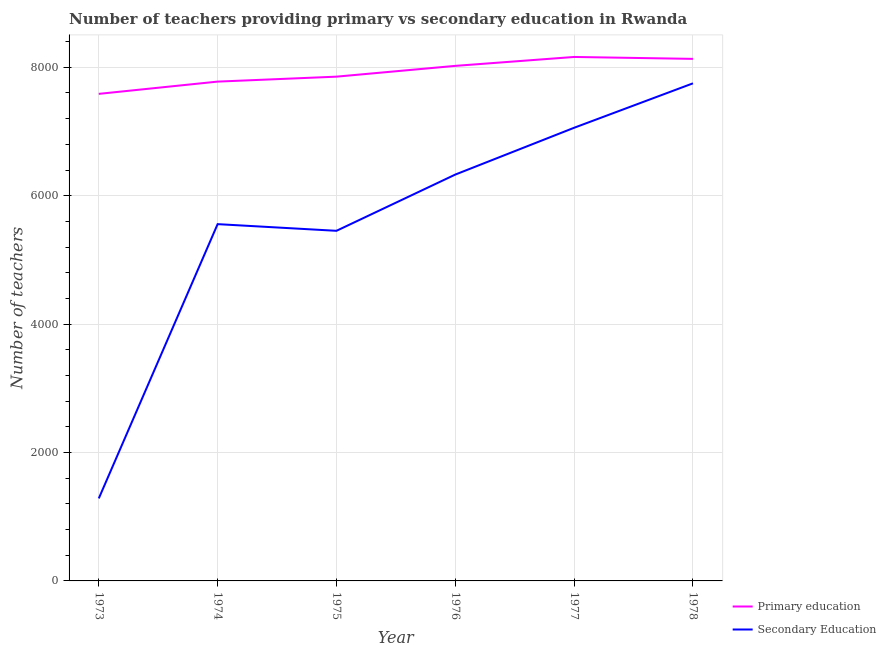Is the number of lines equal to the number of legend labels?
Give a very brief answer. Yes. What is the number of secondary teachers in 1978?
Give a very brief answer. 7750. Across all years, what is the maximum number of secondary teachers?
Your answer should be very brief. 7750. Across all years, what is the minimum number of secondary teachers?
Your answer should be very brief. 1285. In which year was the number of secondary teachers maximum?
Offer a very short reply. 1978. What is the total number of secondary teachers in the graph?
Your response must be concise. 3.34e+04. What is the difference between the number of primary teachers in 1974 and that in 1978?
Your answer should be compact. -354. What is the difference between the number of secondary teachers in 1974 and the number of primary teachers in 1973?
Provide a succinct answer. -2029. What is the average number of secondary teachers per year?
Ensure brevity in your answer.  5572. In the year 1974, what is the difference between the number of primary teachers and number of secondary teachers?
Your response must be concise. 2220. What is the ratio of the number of primary teachers in 1974 to that in 1977?
Offer a terse response. 0.95. Is the number of secondary teachers in 1973 less than that in 1975?
Your answer should be very brief. Yes. Is the difference between the number of primary teachers in 1974 and 1978 greater than the difference between the number of secondary teachers in 1974 and 1978?
Your response must be concise. Yes. What is the difference between the highest and the second highest number of secondary teachers?
Give a very brief answer. 692. What is the difference between the highest and the lowest number of secondary teachers?
Your answer should be very brief. 6465. Is the number of primary teachers strictly greater than the number of secondary teachers over the years?
Offer a very short reply. Yes. How many lines are there?
Offer a very short reply. 2. How many years are there in the graph?
Provide a short and direct response. 6. What is the difference between two consecutive major ticks on the Y-axis?
Keep it short and to the point. 2000. Does the graph contain any zero values?
Provide a short and direct response. No. Where does the legend appear in the graph?
Your response must be concise. Bottom right. How are the legend labels stacked?
Your answer should be very brief. Vertical. What is the title of the graph?
Your response must be concise. Number of teachers providing primary vs secondary education in Rwanda. Does "Commercial service exports" appear as one of the legend labels in the graph?
Ensure brevity in your answer.  No. What is the label or title of the Y-axis?
Ensure brevity in your answer.  Number of teachers. What is the Number of teachers in Primary education in 1973?
Provide a short and direct response. 7586. What is the Number of teachers in Secondary Education in 1973?
Your answer should be compact. 1285. What is the Number of teachers of Primary education in 1974?
Provide a succinct answer. 7777. What is the Number of teachers of Secondary Education in 1974?
Offer a terse response. 5557. What is the Number of teachers in Primary education in 1975?
Offer a terse response. 7854. What is the Number of teachers in Secondary Education in 1975?
Make the answer very short. 5453. What is the Number of teachers of Primary education in 1976?
Give a very brief answer. 8022. What is the Number of teachers of Secondary Education in 1976?
Give a very brief answer. 6329. What is the Number of teachers in Primary education in 1977?
Offer a terse response. 8161. What is the Number of teachers of Secondary Education in 1977?
Make the answer very short. 7058. What is the Number of teachers in Primary education in 1978?
Your answer should be very brief. 8131. What is the Number of teachers of Secondary Education in 1978?
Provide a succinct answer. 7750. Across all years, what is the maximum Number of teachers in Primary education?
Your answer should be compact. 8161. Across all years, what is the maximum Number of teachers of Secondary Education?
Provide a succinct answer. 7750. Across all years, what is the minimum Number of teachers of Primary education?
Keep it short and to the point. 7586. Across all years, what is the minimum Number of teachers in Secondary Education?
Provide a short and direct response. 1285. What is the total Number of teachers of Primary education in the graph?
Offer a terse response. 4.75e+04. What is the total Number of teachers of Secondary Education in the graph?
Give a very brief answer. 3.34e+04. What is the difference between the Number of teachers of Primary education in 1973 and that in 1974?
Ensure brevity in your answer.  -191. What is the difference between the Number of teachers of Secondary Education in 1973 and that in 1974?
Your answer should be very brief. -4272. What is the difference between the Number of teachers in Primary education in 1973 and that in 1975?
Your response must be concise. -268. What is the difference between the Number of teachers in Secondary Education in 1973 and that in 1975?
Offer a terse response. -4168. What is the difference between the Number of teachers in Primary education in 1973 and that in 1976?
Your answer should be very brief. -436. What is the difference between the Number of teachers in Secondary Education in 1973 and that in 1976?
Make the answer very short. -5044. What is the difference between the Number of teachers in Primary education in 1973 and that in 1977?
Your answer should be very brief. -575. What is the difference between the Number of teachers in Secondary Education in 1973 and that in 1977?
Ensure brevity in your answer.  -5773. What is the difference between the Number of teachers in Primary education in 1973 and that in 1978?
Make the answer very short. -545. What is the difference between the Number of teachers of Secondary Education in 1973 and that in 1978?
Ensure brevity in your answer.  -6465. What is the difference between the Number of teachers of Primary education in 1974 and that in 1975?
Offer a very short reply. -77. What is the difference between the Number of teachers of Secondary Education in 1974 and that in 1975?
Your response must be concise. 104. What is the difference between the Number of teachers of Primary education in 1974 and that in 1976?
Ensure brevity in your answer.  -245. What is the difference between the Number of teachers in Secondary Education in 1974 and that in 1976?
Provide a succinct answer. -772. What is the difference between the Number of teachers in Primary education in 1974 and that in 1977?
Offer a terse response. -384. What is the difference between the Number of teachers of Secondary Education in 1974 and that in 1977?
Provide a succinct answer. -1501. What is the difference between the Number of teachers of Primary education in 1974 and that in 1978?
Give a very brief answer. -354. What is the difference between the Number of teachers of Secondary Education in 1974 and that in 1978?
Your answer should be very brief. -2193. What is the difference between the Number of teachers in Primary education in 1975 and that in 1976?
Make the answer very short. -168. What is the difference between the Number of teachers of Secondary Education in 1975 and that in 1976?
Provide a short and direct response. -876. What is the difference between the Number of teachers in Primary education in 1975 and that in 1977?
Ensure brevity in your answer.  -307. What is the difference between the Number of teachers of Secondary Education in 1975 and that in 1977?
Provide a succinct answer. -1605. What is the difference between the Number of teachers in Primary education in 1975 and that in 1978?
Provide a short and direct response. -277. What is the difference between the Number of teachers in Secondary Education in 1975 and that in 1978?
Offer a very short reply. -2297. What is the difference between the Number of teachers in Primary education in 1976 and that in 1977?
Keep it short and to the point. -139. What is the difference between the Number of teachers in Secondary Education in 1976 and that in 1977?
Keep it short and to the point. -729. What is the difference between the Number of teachers of Primary education in 1976 and that in 1978?
Keep it short and to the point. -109. What is the difference between the Number of teachers of Secondary Education in 1976 and that in 1978?
Ensure brevity in your answer.  -1421. What is the difference between the Number of teachers in Primary education in 1977 and that in 1978?
Ensure brevity in your answer.  30. What is the difference between the Number of teachers in Secondary Education in 1977 and that in 1978?
Provide a short and direct response. -692. What is the difference between the Number of teachers of Primary education in 1973 and the Number of teachers of Secondary Education in 1974?
Your response must be concise. 2029. What is the difference between the Number of teachers in Primary education in 1973 and the Number of teachers in Secondary Education in 1975?
Offer a very short reply. 2133. What is the difference between the Number of teachers in Primary education in 1973 and the Number of teachers in Secondary Education in 1976?
Give a very brief answer. 1257. What is the difference between the Number of teachers of Primary education in 1973 and the Number of teachers of Secondary Education in 1977?
Give a very brief answer. 528. What is the difference between the Number of teachers in Primary education in 1973 and the Number of teachers in Secondary Education in 1978?
Provide a short and direct response. -164. What is the difference between the Number of teachers in Primary education in 1974 and the Number of teachers in Secondary Education in 1975?
Give a very brief answer. 2324. What is the difference between the Number of teachers of Primary education in 1974 and the Number of teachers of Secondary Education in 1976?
Offer a very short reply. 1448. What is the difference between the Number of teachers of Primary education in 1974 and the Number of teachers of Secondary Education in 1977?
Offer a very short reply. 719. What is the difference between the Number of teachers of Primary education in 1974 and the Number of teachers of Secondary Education in 1978?
Your answer should be compact. 27. What is the difference between the Number of teachers of Primary education in 1975 and the Number of teachers of Secondary Education in 1976?
Offer a terse response. 1525. What is the difference between the Number of teachers in Primary education in 1975 and the Number of teachers in Secondary Education in 1977?
Your answer should be very brief. 796. What is the difference between the Number of teachers in Primary education in 1975 and the Number of teachers in Secondary Education in 1978?
Offer a very short reply. 104. What is the difference between the Number of teachers in Primary education in 1976 and the Number of teachers in Secondary Education in 1977?
Ensure brevity in your answer.  964. What is the difference between the Number of teachers of Primary education in 1976 and the Number of teachers of Secondary Education in 1978?
Provide a short and direct response. 272. What is the difference between the Number of teachers of Primary education in 1977 and the Number of teachers of Secondary Education in 1978?
Ensure brevity in your answer.  411. What is the average Number of teachers of Primary education per year?
Provide a short and direct response. 7921.83. What is the average Number of teachers in Secondary Education per year?
Provide a succinct answer. 5572. In the year 1973, what is the difference between the Number of teachers of Primary education and Number of teachers of Secondary Education?
Keep it short and to the point. 6301. In the year 1974, what is the difference between the Number of teachers of Primary education and Number of teachers of Secondary Education?
Provide a short and direct response. 2220. In the year 1975, what is the difference between the Number of teachers in Primary education and Number of teachers in Secondary Education?
Offer a very short reply. 2401. In the year 1976, what is the difference between the Number of teachers of Primary education and Number of teachers of Secondary Education?
Offer a terse response. 1693. In the year 1977, what is the difference between the Number of teachers in Primary education and Number of teachers in Secondary Education?
Your answer should be compact. 1103. In the year 1978, what is the difference between the Number of teachers of Primary education and Number of teachers of Secondary Education?
Offer a terse response. 381. What is the ratio of the Number of teachers in Primary education in 1973 to that in 1974?
Your answer should be compact. 0.98. What is the ratio of the Number of teachers in Secondary Education in 1973 to that in 1974?
Provide a short and direct response. 0.23. What is the ratio of the Number of teachers in Primary education in 1973 to that in 1975?
Offer a terse response. 0.97. What is the ratio of the Number of teachers in Secondary Education in 1973 to that in 1975?
Offer a very short reply. 0.24. What is the ratio of the Number of teachers of Primary education in 1973 to that in 1976?
Offer a terse response. 0.95. What is the ratio of the Number of teachers in Secondary Education in 1973 to that in 1976?
Your answer should be very brief. 0.2. What is the ratio of the Number of teachers in Primary education in 1973 to that in 1977?
Your response must be concise. 0.93. What is the ratio of the Number of teachers of Secondary Education in 1973 to that in 1977?
Your response must be concise. 0.18. What is the ratio of the Number of teachers of Primary education in 1973 to that in 1978?
Your response must be concise. 0.93. What is the ratio of the Number of teachers of Secondary Education in 1973 to that in 1978?
Your answer should be compact. 0.17. What is the ratio of the Number of teachers of Primary education in 1974 to that in 1975?
Keep it short and to the point. 0.99. What is the ratio of the Number of teachers of Secondary Education in 1974 to that in 1975?
Provide a succinct answer. 1.02. What is the ratio of the Number of teachers of Primary education in 1974 to that in 1976?
Keep it short and to the point. 0.97. What is the ratio of the Number of teachers of Secondary Education in 1974 to that in 1976?
Provide a short and direct response. 0.88. What is the ratio of the Number of teachers in Primary education in 1974 to that in 1977?
Your answer should be compact. 0.95. What is the ratio of the Number of teachers of Secondary Education in 1974 to that in 1977?
Offer a very short reply. 0.79. What is the ratio of the Number of teachers in Primary education in 1974 to that in 1978?
Your response must be concise. 0.96. What is the ratio of the Number of teachers of Secondary Education in 1974 to that in 1978?
Provide a short and direct response. 0.72. What is the ratio of the Number of teachers of Primary education in 1975 to that in 1976?
Your answer should be compact. 0.98. What is the ratio of the Number of teachers in Secondary Education in 1975 to that in 1976?
Your answer should be very brief. 0.86. What is the ratio of the Number of teachers of Primary education in 1975 to that in 1977?
Ensure brevity in your answer.  0.96. What is the ratio of the Number of teachers in Secondary Education in 1975 to that in 1977?
Ensure brevity in your answer.  0.77. What is the ratio of the Number of teachers of Primary education in 1975 to that in 1978?
Your answer should be very brief. 0.97. What is the ratio of the Number of teachers in Secondary Education in 1975 to that in 1978?
Keep it short and to the point. 0.7. What is the ratio of the Number of teachers in Secondary Education in 1976 to that in 1977?
Offer a terse response. 0.9. What is the ratio of the Number of teachers in Primary education in 1976 to that in 1978?
Keep it short and to the point. 0.99. What is the ratio of the Number of teachers in Secondary Education in 1976 to that in 1978?
Your answer should be compact. 0.82. What is the ratio of the Number of teachers in Primary education in 1977 to that in 1978?
Offer a very short reply. 1. What is the ratio of the Number of teachers of Secondary Education in 1977 to that in 1978?
Your answer should be very brief. 0.91. What is the difference between the highest and the second highest Number of teachers in Primary education?
Provide a succinct answer. 30. What is the difference between the highest and the second highest Number of teachers of Secondary Education?
Your answer should be very brief. 692. What is the difference between the highest and the lowest Number of teachers in Primary education?
Offer a terse response. 575. What is the difference between the highest and the lowest Number of teachers in Secondary Education?
Provide a short and direct response. 6465. 